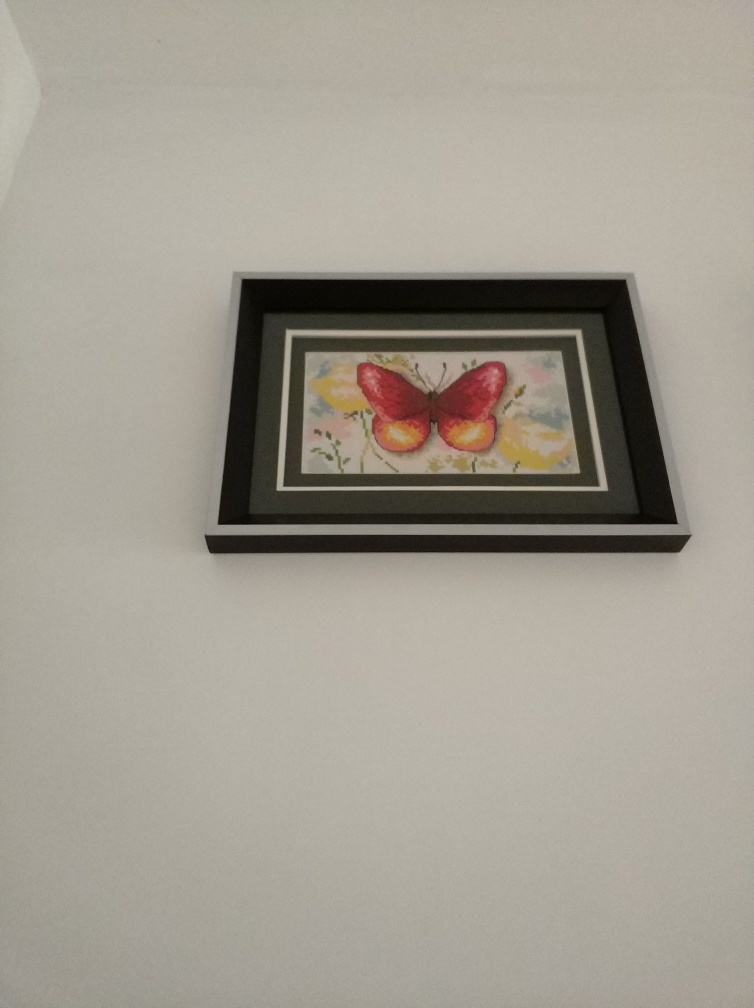Can you comment on the use of light and shadow in this piece? While the image does not display a strong contrast between light and shadow, the butterfly's wings have subtle shading that provides a sense of volume and depth. The backdrop's soft gradient creates an illusion of a gentle glow, suggesting ambient light that complements the serene atmosphere of the composition. 